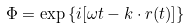<formula> <loc_0><loc_0><loc_500><loc_500>\Phi = \exp { \{ i [ \omega t - { k } \cdot { r } ( t ) ] \} }</formula> 